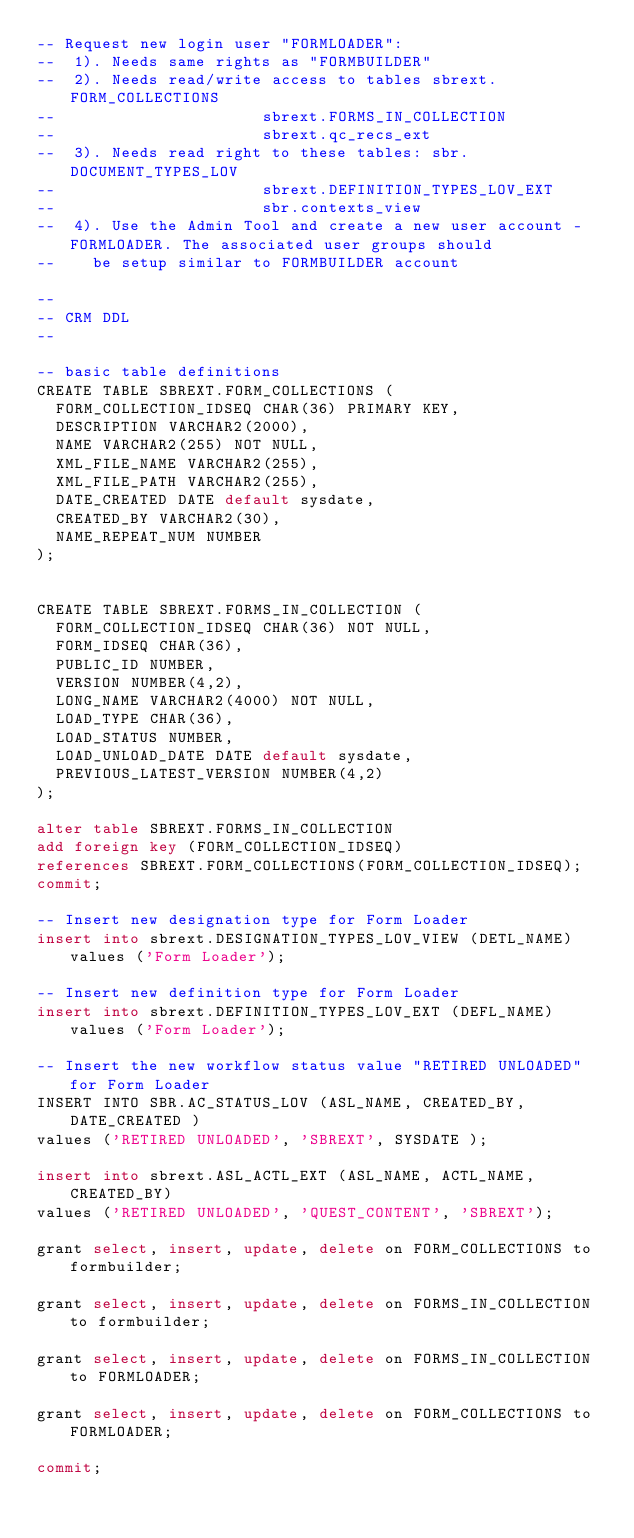Convert code to text. <code><loc_0><loc_0><loc_500><loc_500><_SQL_>-- Request new login user "FORMLOADER":
--	1). Needs same rights as "FORMBUILDER"
--  2). Needs read/write access to tables sbrext.FORM_COLLECTIONS
--											sbrext.FORMS_IN_COLLECTION
--											sbrext.qc_recs_ext
-- 	3). Needs read right to these tables: sbr.DOCUMENT_TYPES_LOV
--											sbrext.DEFINITION_TYPES_LOV_EXT 
--	 										sbr.contexts_view 
--	4). Use the Admin Tool and create a new user account - FORMLOADER. The associated user groups should 
--		be setup similar to FORMBUILDER account

--
-- CRM DDL
--

-- basic table definitions
CREATE TABLE SBREXT.FORM_COLLECTIONS (
  FORM_COLLECTION_IDSEQ CHAR(36) PRIMARY KEY,
  DESCRIPTION VARCHAR2(2000),
  NAME VARCHAR2(255) NOT NULL,
  XML_FILE_NAME VARCHAR2(255),
  XML_FILE_PATH VARCHAR2(255),
  DATE_CREATED DATE default sysdate,
  CREATED_BY VARCHAR2(30),
  NAME_REPEAT_NUM NUMBER
);


CREATE TABLE SBREXT.FORMS_IN_COLLECTION (
  FORM_COLLECTION_IDSEQ CHAR(36) NOT NULL,
  FORM_IDSEQ CHAR(36),
  PUBLIC_ID NUMBER, 
  VERSION NUMBER(4,2),
  LONG_NAME VARCHAR2(4000) NOT NULL,
  LOAD_TYPE CHAR(36),
  LOAD_STATUS NUMBER,
  LOAD_UNLOAD_DATE DATE default sysdate,
  PREVIOUS_LATEST_VERSION NUMBER(4,2)
);

alter table SBREXT.FORMS_IN_COLLECTION 
add foreign key (FORM_COLLECTION_IDSEQ) 
references SBREXT.FORM_COLLECTIONS(FORM_COLLECTION_IDSEQ);
commit;

-- Insert new designation type for Form Loader
insert into sbrext.DESIGNATION_TYPES_LOV_VIEW (DETL_NAME) values ('Form Loader');

-- Insert new definition type for Form Loader
insert into sbrext.DEFINITION_TYPES_LOV_EXT (DEFL_NAME) values ('Form Loader');

-- Insert the new workflow status value "RETIRED UNLOADED" for Form Loader
INSERT INTO SBR.AC_STATUS_LOV (ASL_NAME, CREATED_BY, DATE_CREATED )
values ('RETIRED UNLOADED', 'SBREXT', SYSDATE );

insert into sbrext.ASL_ACTL_EXT (ASL_NAME, ACTL_NAME, CREATED_BY) 
values ('RETIRED UNLOADED', 'QUEST_CONTENT', 'SBREXT');

grant select, insert, update, delete on FORM_COLLECTIONS to formbuilder;
 
grant select, insert, update, delete on FORMS_IN_COLLECTION to formbuilder;

grant select, insert, update, delete on FORMS_IN_COLLECTION to FORMLOADER;

grant select, insert, update, delete on FORM_COLLECTIONS to FORMLOADER;

commit;
</code> 